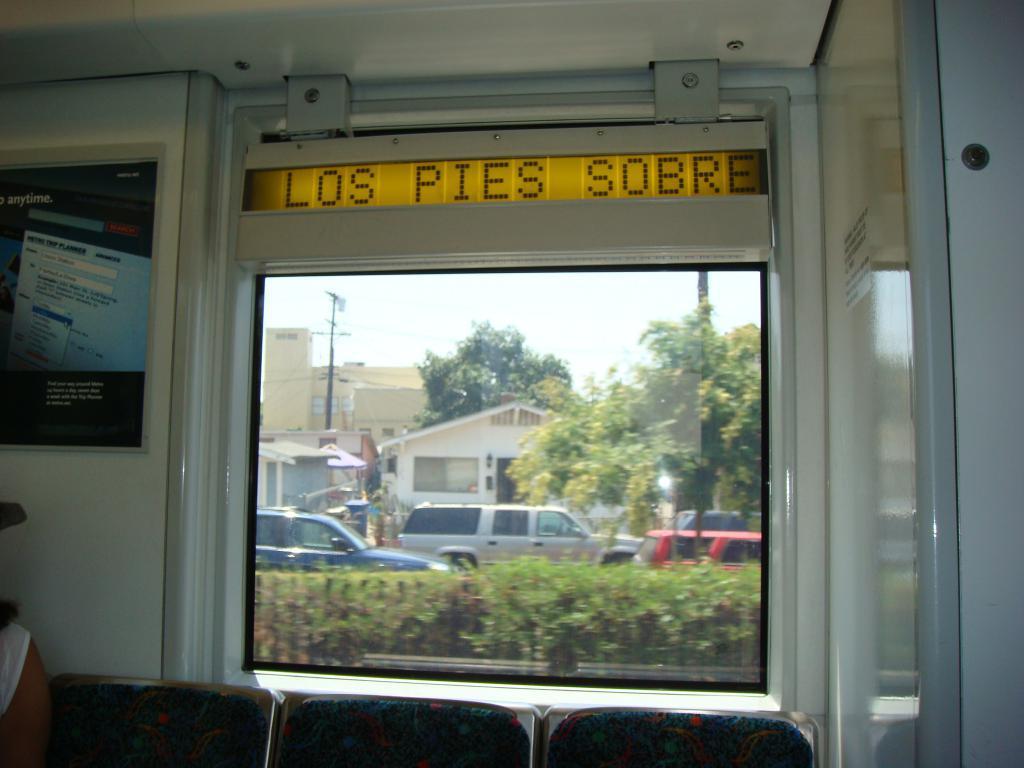Please provide a concise description of this image. This picture shows a inner view of a room. We see chairs and a glass window from the window we see buildings, electric poles and trees and few cars and we see a photo frame on the wall and we see text. 